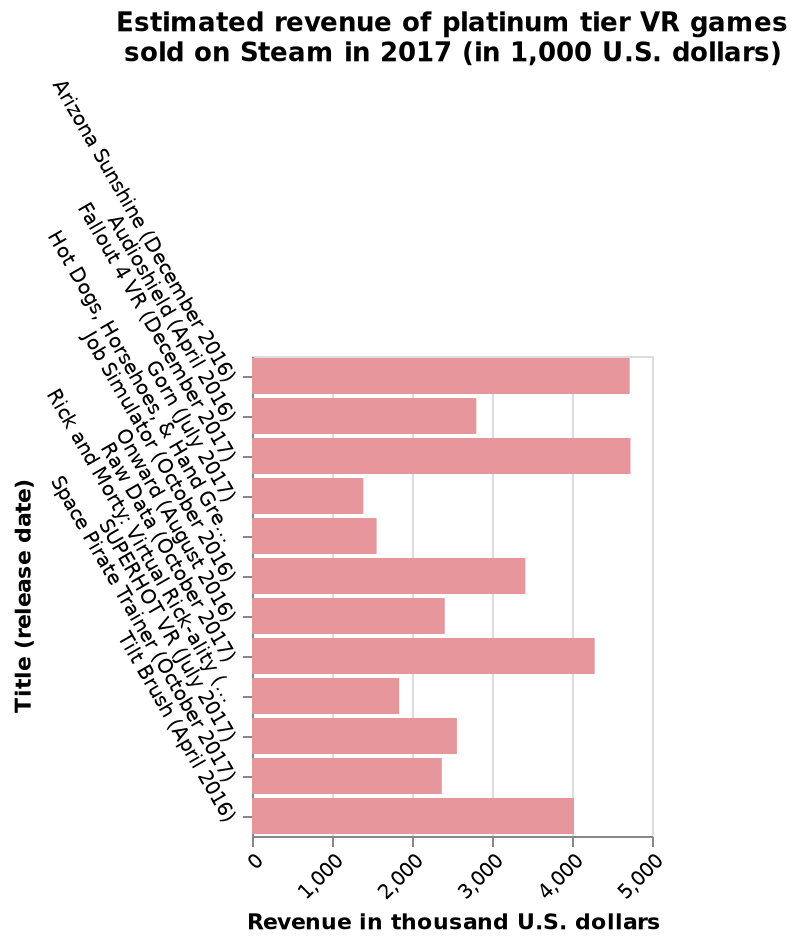<image>
please describe the details of the chart Estimated revenue of platinum tier VR games sold on Steam in 2017 (in 1,000 U.S. dollars) is a bar graph. Title (release date) is measured along a categorical scale starting at Arizona Sunshine (December 2016) and ending at Tilt Brush (April 2016) on the y-axis. Revenue in thousand U.S. dollars is plotted on a linear scale of range 0 to 5,000 on the x-axis. How many VR games achieved revenue of more than $4000 in 2017? Three VR games achieved revenue of more than $4000 in 2017. Which two VR games tied for the highest revenue in 2017?  Arizona Sunshine and Fallout 4 VR tied for the highest revenue in 2017. Which measure is used for the x-axis and which measure is used for the y-axis? The x-axis is measured in thousand U.S. dollars using a linear scale ranging from 0 to 5,000. The y-axis is measured using a categorical scale with the release dates of the games starting from Arizona Sunshine and ending at Tilt Brush. Is the x-axis measured in hundred U.S. dollars using a logarithmic scale ranging from 0 to 10,000? No.The x-axis is measured in thousand U.S. dollars using a linear scale ranging from 0 to 5,000. The y-axis is measured using a categorical scale with the release dates of the games starting from Arizona Sunshine and ending at Tilt Brush. 